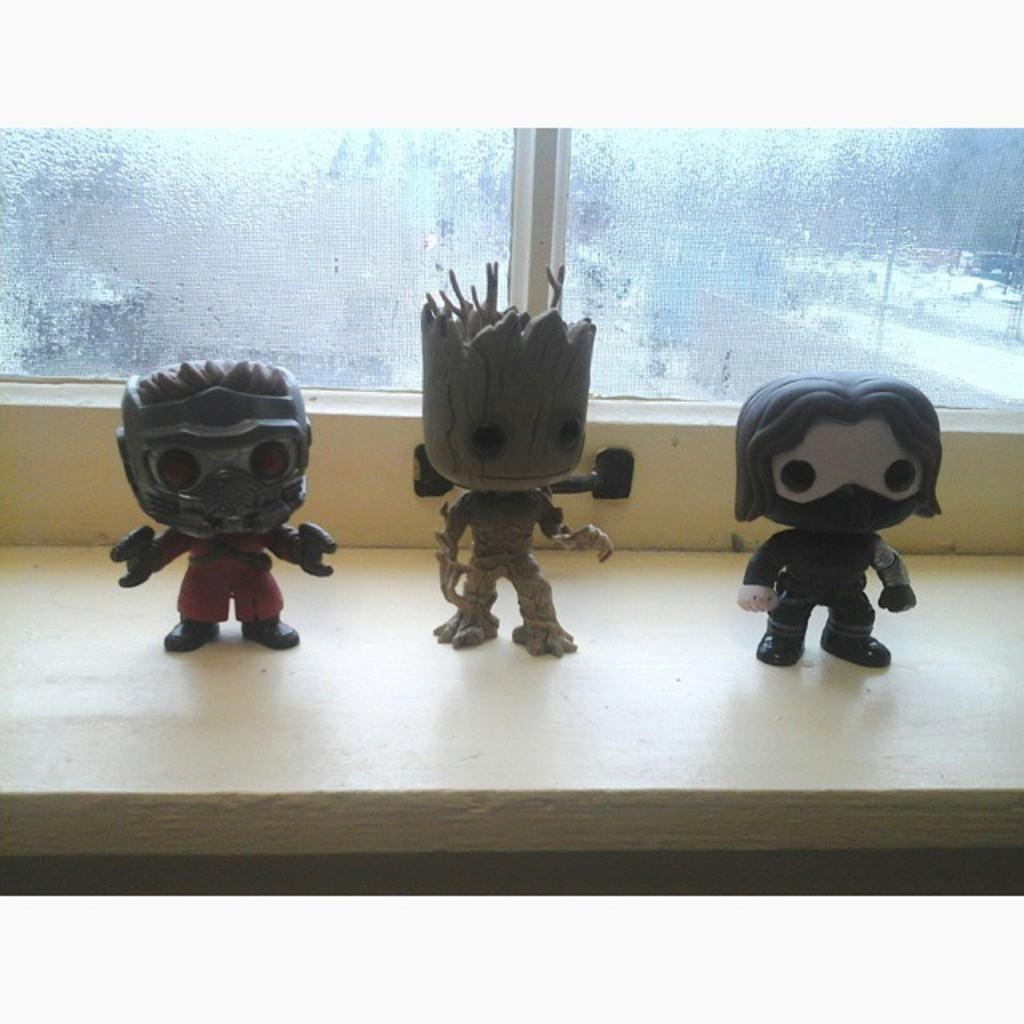How many toys can be seen in the image? There are three toys in the image. Where are the toys located in relation to other elements in the image? The toys are near the windows. Can you identify any specific toy in the image? Yes, there is a Groot toy in the image. What type of windows are present in the image? There are glass windows in the image. What type of stamp can be seen on the Groot toy in the image? There is no stamp present on the Groot toy in the image. How many balloons are floating near the toys in the image? There are no balloons present in the image. 